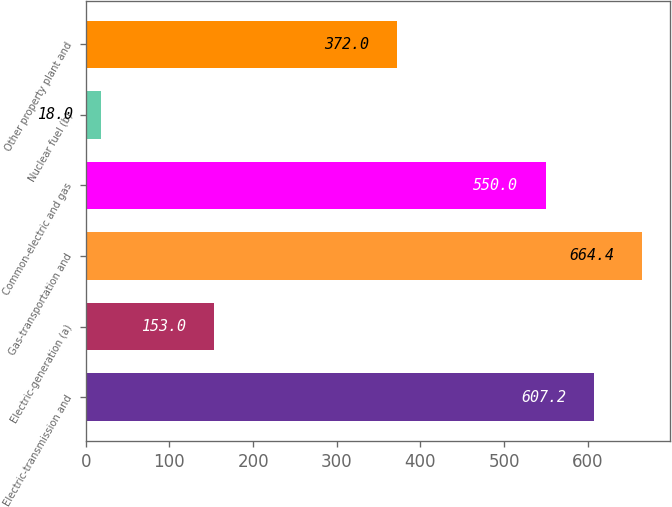<chart> <loc_0><loc_0><loc_500><loc_500><bar_chart><fcel>Electric-transmission and<fcel>Electric-generation (a)<fcel>Gas-transportation and<fcel>Common-electric and gas<fcel>Nuclear fuel (b)<fcel>Other property plant and<nl><fcel>607.2<fcel>153<fcel>664.4<fcel>550<fcel>18<fcel>372<nl></chart> 